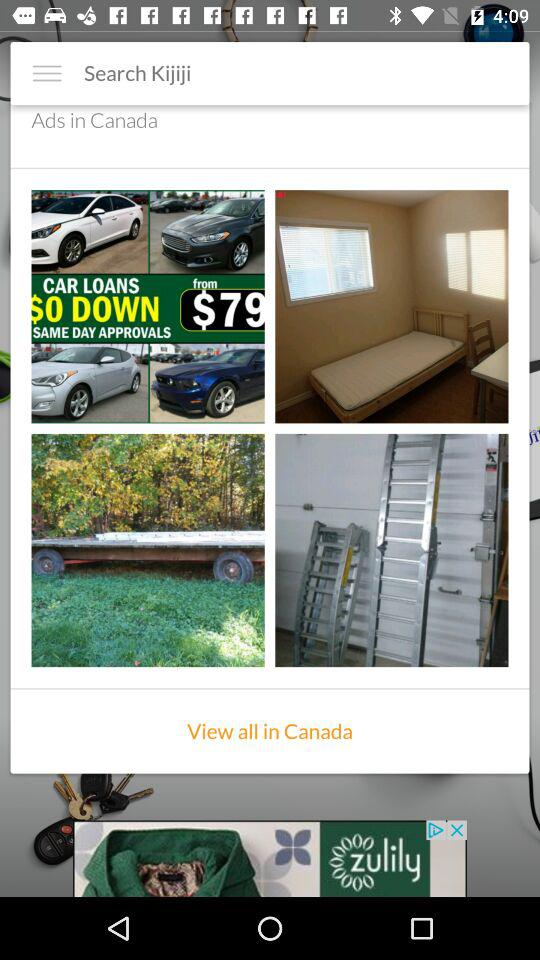Which of the ads are in Canada?
When the provided information is insufficient, respond with <no answer>. <no answer> 